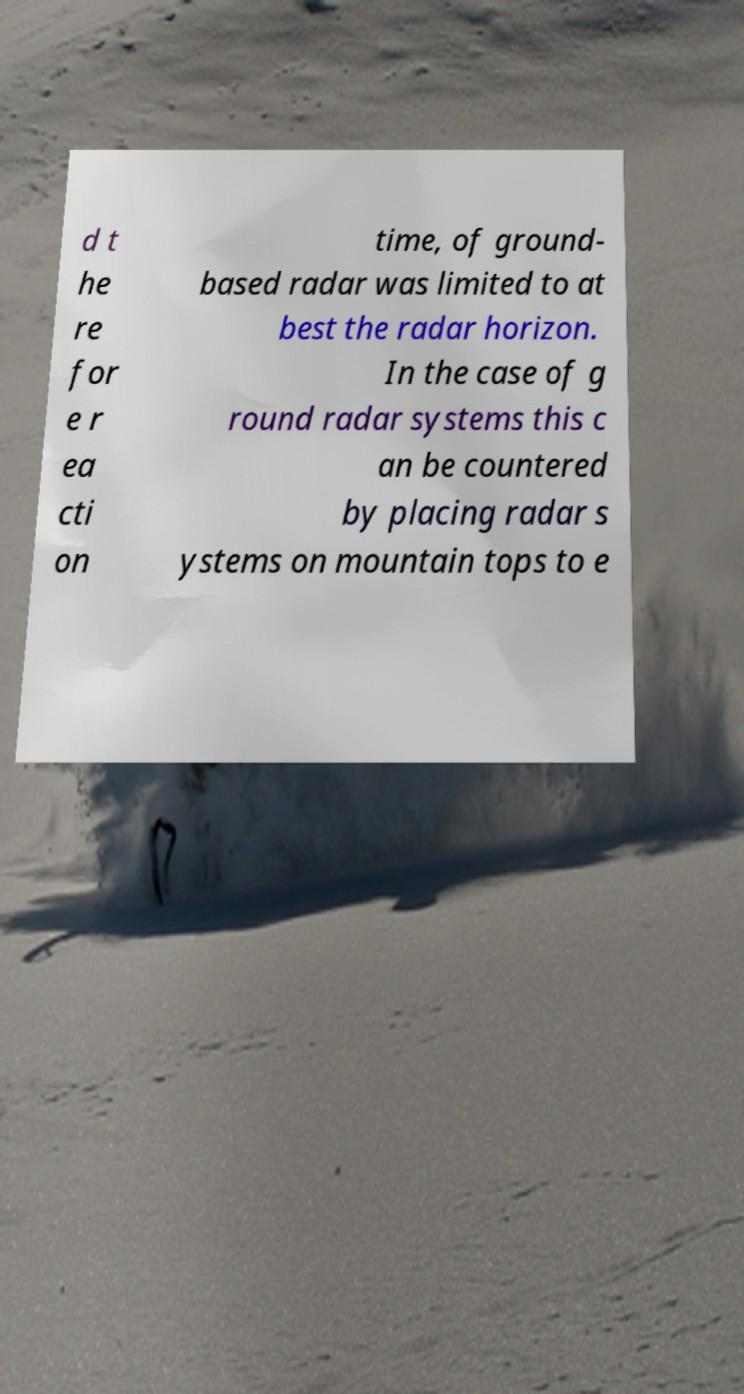Could you assist in decoding the text presented in this image and type it out clearly? d t he re for e r ea cti on time, of ground- based radar was limited to at best the radar horizon. In the case of g round radar systems this c an be countered by placing radar s ystems on mountain tops to e 